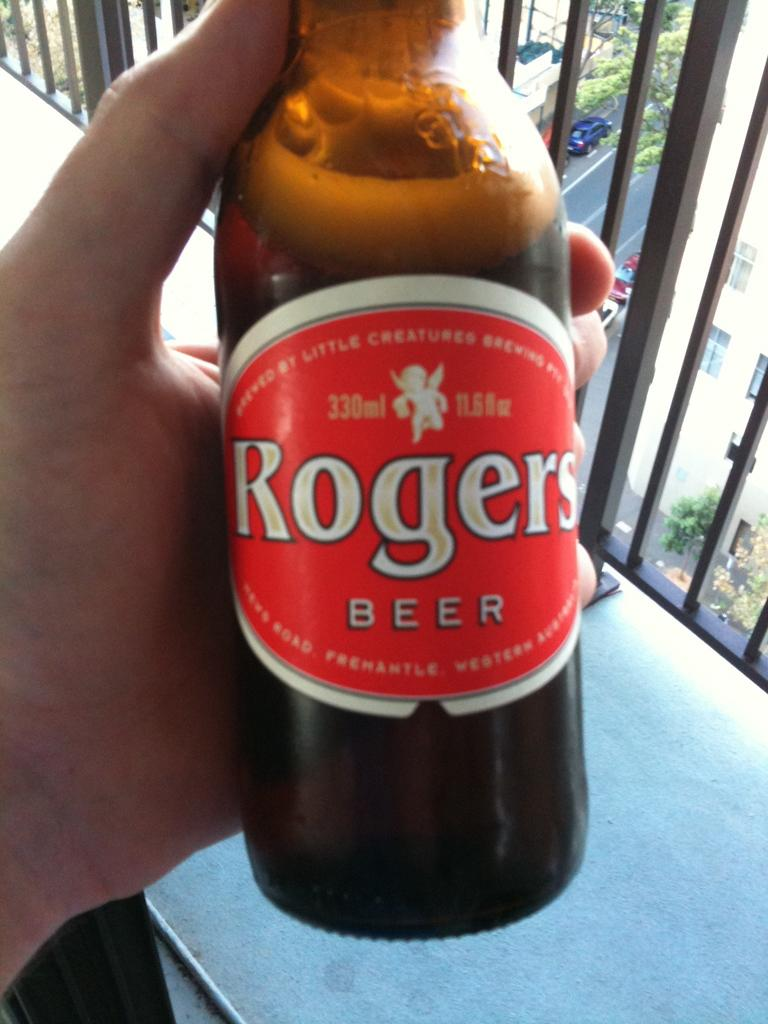<image>
Offer a succinct explanation of the picture presented. A person holding a Rogers beer brand bottle. 